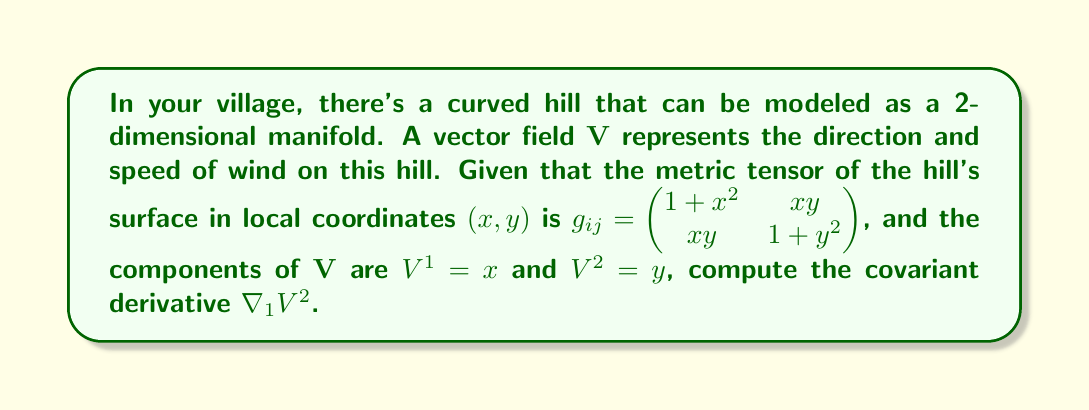Can you solve this math problem? To compute the covariant derivative $\nabla_1 V^2$, we'll follow these steps:

1) The formula for the covariant derivative is:

   $$\nabla_i V^j = \partial_i V^j + \Gamma^j_{ik} V^k$$

   where $\Gamma^j_{ik}$ are the Christoffel symbols.

2) We need to calculate $\partial_1 V^2$ and the relevant Christoffel symbol $\Gamma^2_{11}$.

3) First, $\partial_1 V^2 = \partial_1 y = 0$.

4) To find $\Gamma^2_{11}$, we use the formula:

   $$\Gamma^i_{jk} = \frac{1}{2} g^{im} (\partial_j g_{km} + \partial_k g_{jm} - \partial_m g_{jk})$$

5) We need to calculate $g^{im}$, which is the inverse of $g_{ij}$:

   $$g^{ij} = \frac{1}{(1+x^2)(1+y^2)-x^2y^2} \begin{pmatrix} 1+y^2 & -xy \\ -xy & 1+x^2 \end{pmatrix}$$

6) Now, let's calculate the relevant partial derivatives:

   $\partial_1 g_{11} = 2x$
   $\partial_1 g_{12} = y$
   $\partial_2 g_{11} = 0$

7) Substituting into the Christoffel symbol formula:

   $$\Gamma^2_{11} = \frac{1}{2} (g^{21}(\partial_1 g_{11}) + g^{22}(\partial_1 g_{12}) - g^{22}(\partial_2 g_{11}))$$
   $$= \frac{1}{2} \left(\frac{-xy}{(1+x^2)(1+y^2)-x^2y^2}(2x) + \frac{1+x^2}{(1+x^2)(1+y^2)-x^2y^2}(y) - 0\right)$$
   $$= \frac{-x^2y + y(1+x^2)}{(1+x^2)(1+y^2)-x^2y^2} = \frac{y}{1+y^2}$$

8) Now we can compute the covariant derivative:

   $$\nabla_1 V^2 = \partial_1 V^2 + \Gamma^2_{11} V^1$$
   $$= 0 + \frac{y}{1+y^2} \cdot x$$
   $$= \frac{xy}{1+y^2}$$
Answer: $\frac{xy}{1+y^2}$ 